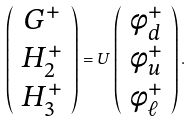Convert formula to latex. <formula><loc_0><loc_0><loc_500><loc_500>\left ( \begin{array} { c } G ^ { + } \\ H _ { 2 } ^ { + } \\ H _ { 3 } ^ { + } \end{array} \right ) = U \left ( \begin{array} { c } \phi _ { d } ^ { + } \\ \phi _ { u } ^ { + } \\ \phi _ { \ell } ^ { + } \end{array} \right ) .</formula> 